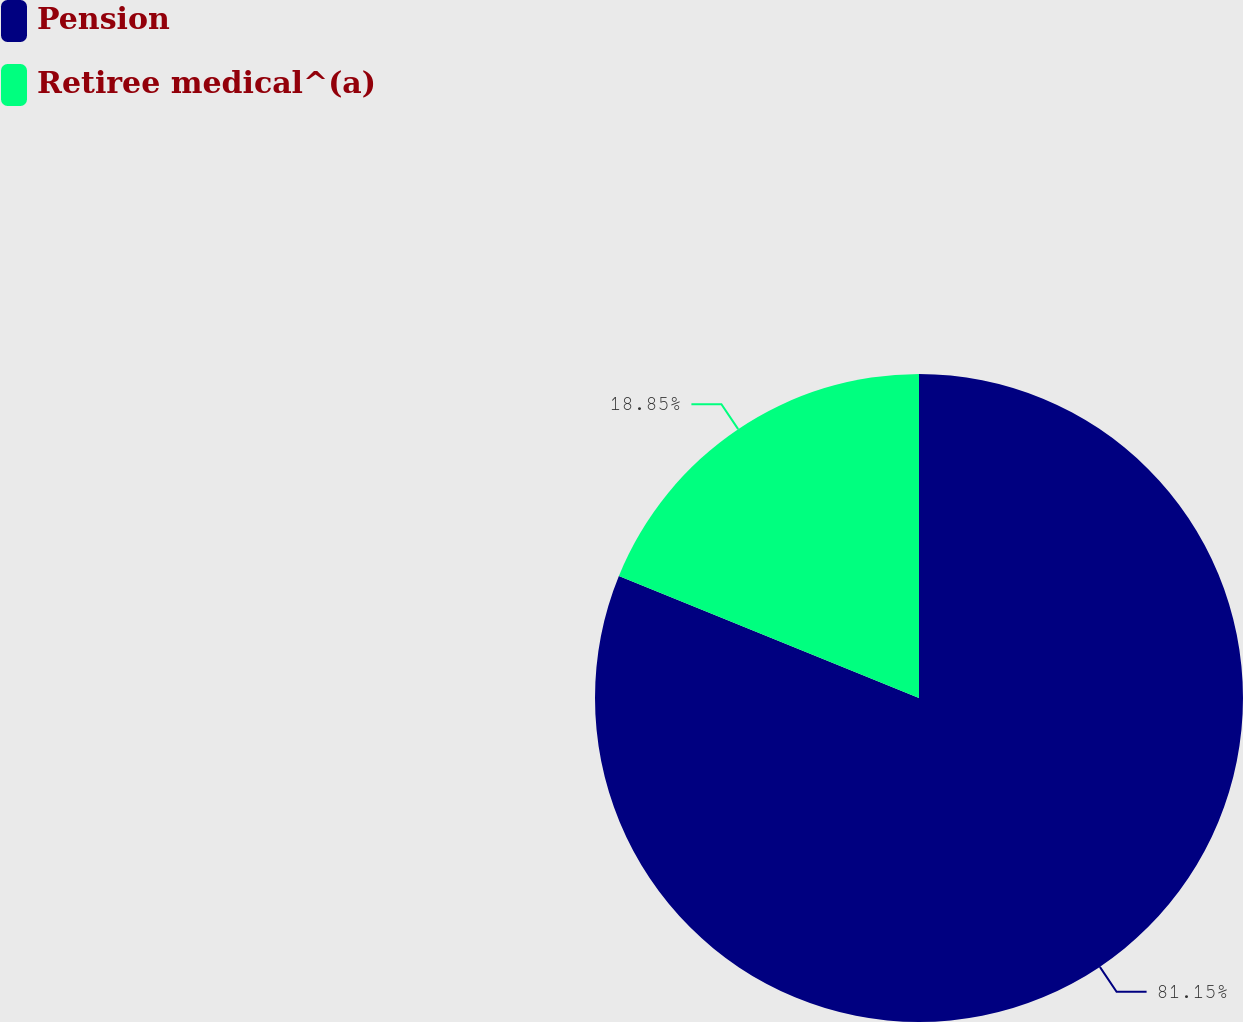Convert chart. <chart><loc_0><loc_0><loc_500><loc_500><pie_chart><fcel>Pension<fcel>Retiree medical^(a)<nl><fcel>81.15%<fcel>18.85%<nl></chart> 